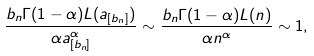<formula> <loc_0><loc_0><loc_500><loc_500>\frac { b _ { n } \Gamma ( 1 - \alpha ) L ( a _ { [ b _ { n } ] } ) } { \alpha a _ { [ b _ { n } ] } ^ { \alpha } } \sim \frac { b _ { n } \Gamma ( 1 - \alpha ) L ( n ) } { \alpha n ^ { \alpha } } \sim 1 ,</formula> 